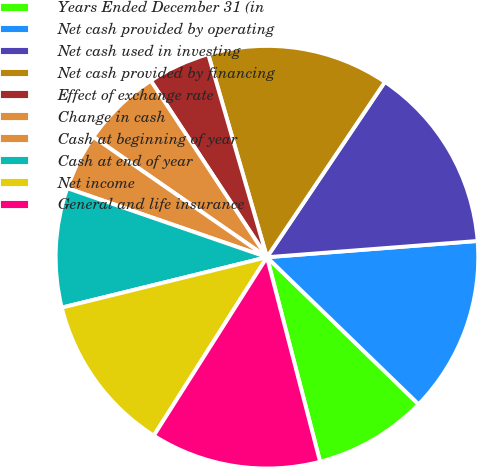<chart> <loc_0><loc_0><loc_500><loc_500><pie_chart><fcel>Years Ended December 31 (in<fcel>Net cash provided by operating<fcel>Net cash used in investing<fcel>Net cash provided by financing<fcel>Effect of exchange rate<fcel>Change in cash<fcel>Cash at beginning of year<fcel>Cash at end of year<fcel>Net income<fcel>General and life insurance<nl><fcel>8.7%<fcel>13.48%<fcel>14.35%<fcel>13.91%<fcel>4.78%<fcel>6.09%<fcel>4.35%<fcel>9.13%<fcel>12.17%<fcel>13.04%<nl></chart> 